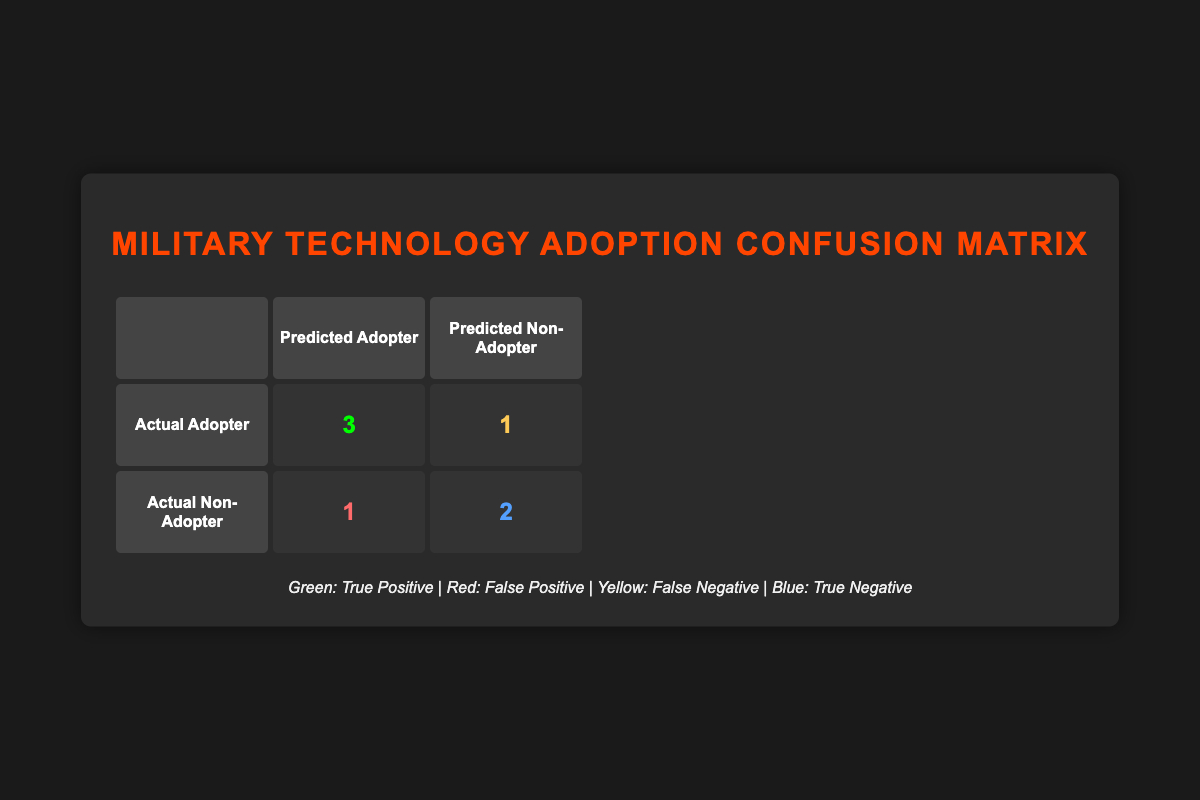What is the total number of true adopters predicted? From the table, we can see the true positive value representing actual adopters who were predicted as adopters is 3. Adding this to zero (as only those values are counted here), the total remains 3.
Answer: 3 What is the number of false negatives? The false negative value in the confusion matrix indicates the number of actual adopters that were incorrectly predicted as non-adopters. Referring to the table, this value is 1.
Answer: 1 What is the total number of countries assessed for military technology adoption? By counting all the countries listed in the data provided, we find there are 8 countries in total.
Answer: 8 How many countries were correctly predicted as adopters? Correctly predicted adopters are represented by true positives, which is 3, plus no other categories contributing to this count. Thus, the total is 3.
Answer: 3 What percentage of actual adopters were correctly predicted? To calculate this, we need to consider the total number of actual adopters (4) and how many were correctly predicted (3). The calculation is (3/4) * 100 = 75%.
Answer: 75% Are there any countries where the prediction was a false positive? A false positive occurs when a country was predicted to adopt but did not. In the table, the value is 1, indicating that there is one such country.
Answer: Yes Which country was the false adopter according to the data? By reviewing the table for false positives, we see that Russia was predicted as an adopter but actually did not adopt the technology.
Answer: Russia How many countries were both predicted and did not adopt the technology? From the table, we can gather that the true negatives value represents countries that were predicted as non-adopters and indeed did not adopt. This value is 2.
Answer: 2 What is the total number of predicted non-adopters? The predicted non-adopter count is the sum of those correctly predicted as non-adopters (true negatives, which is 2) and those incorrectly predicted as adopting (false positives, which is 1), resulting in a total of 3.
Answer: 3 